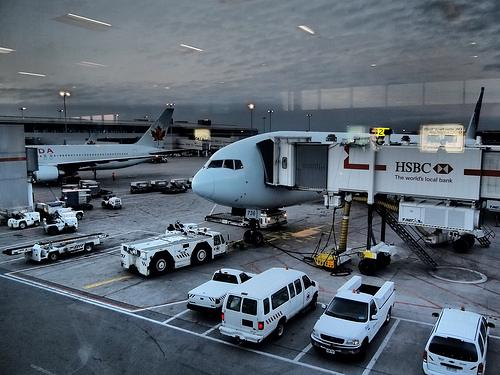Provide a brief overview of the main objects present in the image. The image features parked white vehicles, an airport with parked planes, red lights on a van, and a red maple leaf on the tail of a plane. In one sentence, summarize the main scene depicted in the image. At an airport, aircraft are being unloaded and passengers are boarding, while several white vehicles are parked nearby. Using two adjectives, characterize the main objects in the image. White, parked airplanes and vehicles. Describe two focal points in the image and what they represent. A white airplane unloading passengers represents airport activity, and a white van with red lights on the back indicates parked vehicles. Narrate the primary activities happening in the image. An airplane is unloading passengers, with people boarding the plane, while white vehicles, including a van and a truck, are parked nearby. In a single phrase, describe the most striking aspect of the image. Unloading and boarding of an airplane. In a few words, state the primary setting or environment of the image. Airport with parked airplanes and vehicles. Explain the predominant theme of the image in one sentence. The image displays a bustling airport scene with parked vehicles and ongoing airplane activities. Mention the main colors and prominent objects in the image. The image contains white airplanes and vehicles, red lights on the back of a van, and a red maple leaf on a plane's tail. Detail the specific actions of the main subject in the image. An airplane is unloading passengers, while people are lining up to board, with several parked white vehicles nearby. 